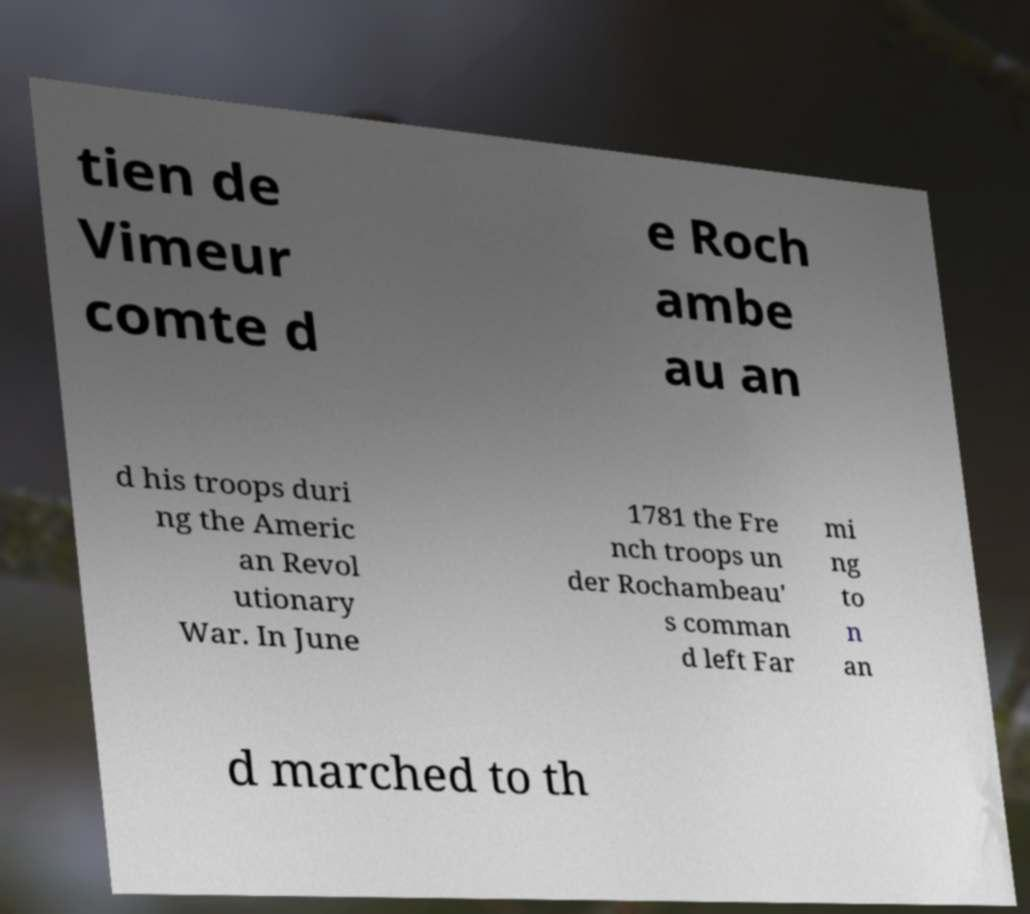Can you read and provide the text displayed in the image?This photo seems to have some interesting text. Can you extract and type it out for me? tien de Vimeur comte d e Roch ambe au an d his troops duri ng the Americ an Revol utionary War. In June 1781 the Fre nch troops un der Rochambeau' s comman d left Far mi ng to n an d marched to th 